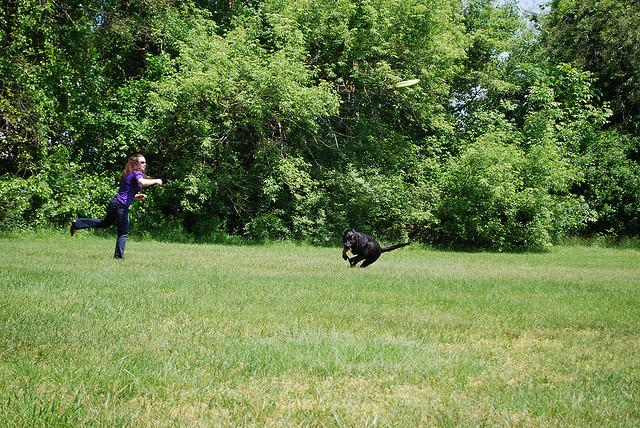What is the woman most likely to be most days of the week? working 